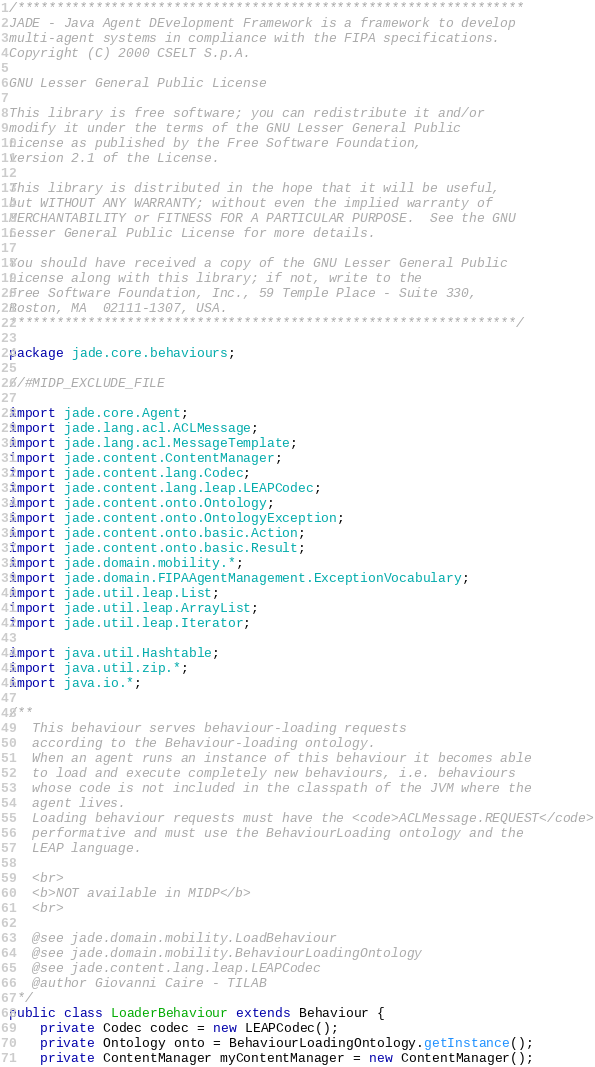Convert code to text. <code><loc_0><loc_0><loc_500><loc_500><_Java_>/*****************************************************************
JADE - Java Agent DEvelopment Framework is a framework to develop
multi-agent systems in compliance with the FIPA specifications.
Copyright (C) 2000 CSELT S.p.A.

GNU Lesser General Public License

This library is free software; you can redistribute it and/or
modify it under the terms of the GNU Lesser General Public
License as published by the Free Software Foundation,
version 2.1 of the License.

This library is distributed in the hope that it will be useful,
but WITHOUT ANY WARRANTY; without even the implied warranty of
MERCHANTABILITY or FITNESS FOR A PARTICULAR PURPOSE.  See the GNU
Lesser General Public License for more details.

You should have received a copy of the GNU Lesser General Public
License along with this library; if not, write to the
Free Software Foundation, Inc., 59 Temple Place - Suite 330,
Boston, MA  02111-1307, USA.
*****************************************************************/

package jade.core.behaviours;

//#MIDP_EXCLUDE_FILE

import jade.core.Agent;
import jade.lang.acl.ACLMessage;
import jade.lang.acl.MessageTemplate;
import jade.content.ContentManager;
import jade.content.lang.Codec;
import jade.content.lang.leap.LEAPCodec;
import jade.content.onto.Ontology;
import jade.content.onto.OntologyException;
import jade.content.onto.basic.Action;
import jade.content.onto.basic.Result;
import jade.domain.mobility.*;
import jade.domain.FIPAAgentManagement.ExceptionVocabulary;
import jade.util.leap.List;
import jade.util.leap.ArrayList;
import jade.util.leap.Iterator;

import java.util.Hashtable;
import java.util.zip.*;
import java.io.*;

/**
   This behaviour serves behaviour-loading requests
   according to the Behaviour-loading ontology.
   When an agent runs an instance of this behaviour it becomes able
   to load and execute completely new behaviours, i.e. behaviours
   whose code is not included in the classpath of the JVM where the 
   agent lives.
   Loading behaviour requests must have the <code>ACLMessage.REQUEST</code>
   performative and must use the BehaviourLoading ontology and the
   LEAP language.
   
   <br>
   <b>NOT available in MIDP</b>
   <br>
      
   @see jade.domain.mobility.LoadBehaviour
   @see jade.domain.mobility.BehaviourLoadingOntology
   @see jade.content.lang.leap.LEAPCodec
   @author Giovanni Caire - TILAB
 */
public class LoaderBehaviour extends Behaviour {
	private Codec codec = new LEAPCodec();
	private Ontology onto = BehaviourLoadingOntology.getInstance();
	private ContentManager myContentManager = new ContentManager();</code> 